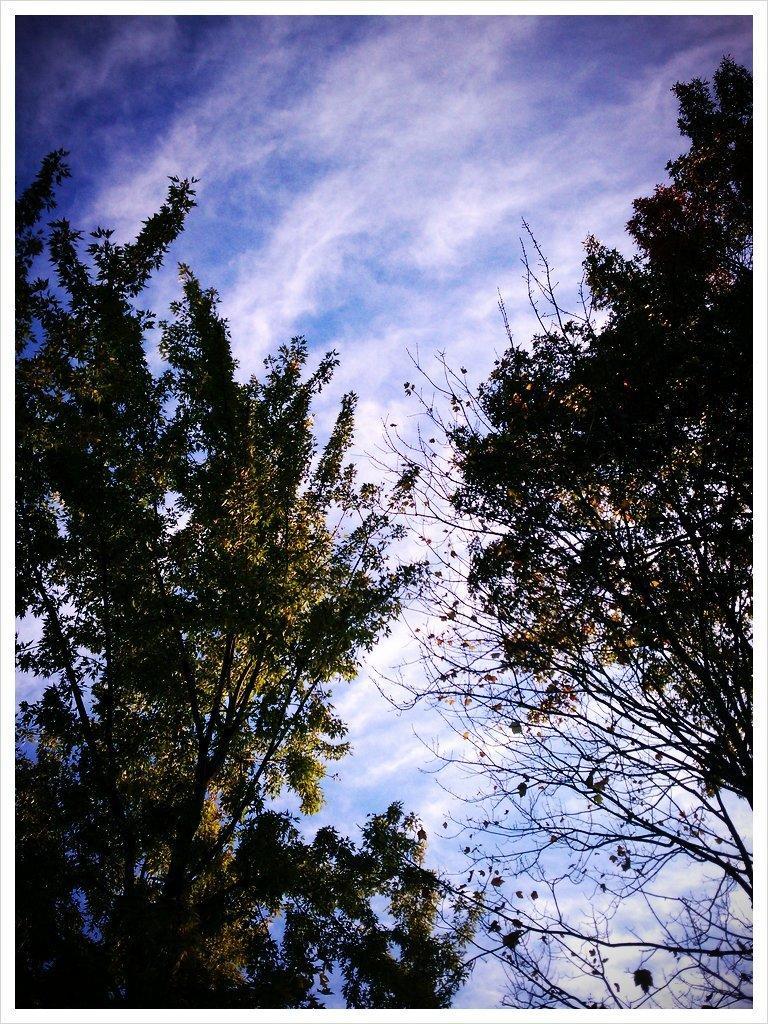In one or two sentences, can you explain what this image depicts? In this image, we can see trees. Background there is the sky. 